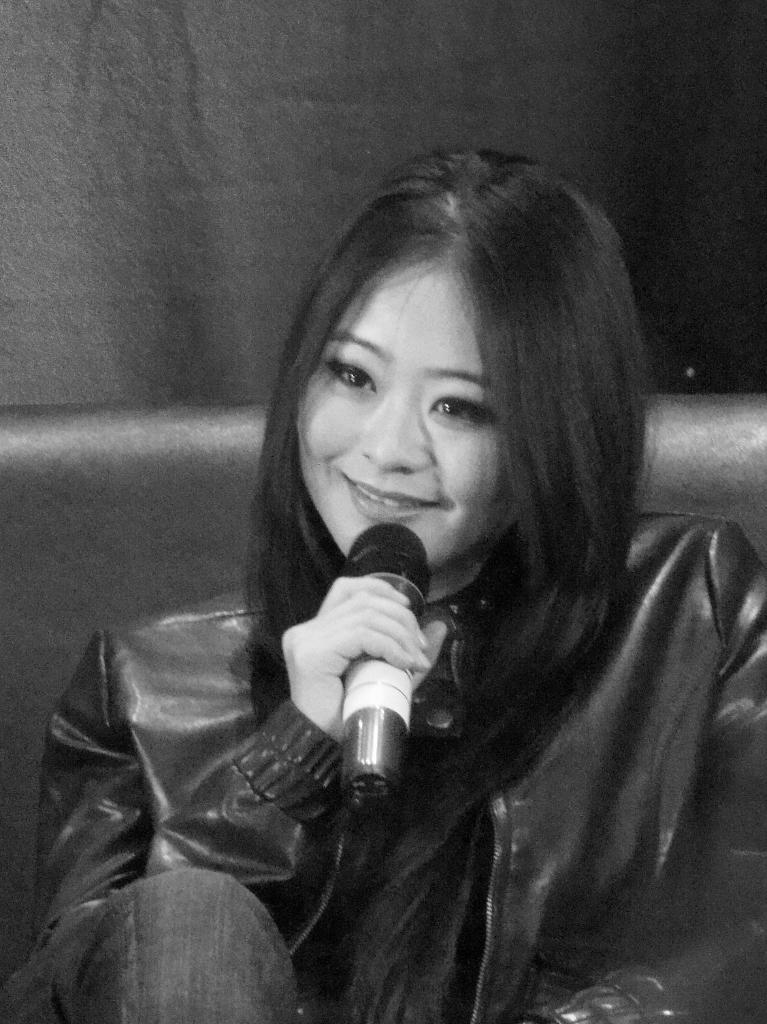What is the color scheme of the image? The image is black and white. Who is present in the image? There is a woman in the image. What is the woman wearing? The woman is wearing a jacket. What is the woman holding in the image? The woman is holding a mic. What is the woman's posture in the image? The woman appears to be sleeping. What is the woman sitting on in the image? The woman is sitting on a sofa. What is visible behind the woman in the image? There is a curtain behind the woman. How many snakes can be seen slithering around the woman's collar in the image? There are no snakes present in the image, and the woman is not wearing a collar. 